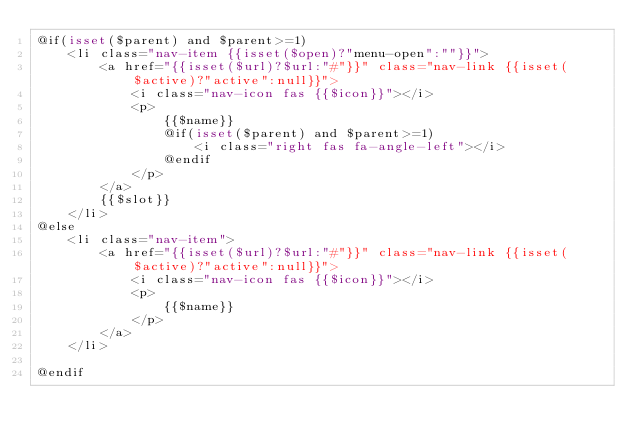<code> <loc_0><loc_0><loc_500><loc_500><_PHP_>@if(isset($parent) and $parent>=1)
    <li class="nav-item {{isset($open)?"menu-open":""}}">
        <a href="{{isset($url)?$url:"#"}}" class="nav-link {{isset($active)?"active":null}}">
            <i class="nav-icon fas {{$icon}}"></i>
            <p>
                {{$name}}
                @if(isset($parent) and $parent>=1)
                    <i class="right fas fa-angle-left"></i>
                @endif
            </p>
        </a>
        {{$slot}}
    </li>
@else
    <li class="nav-item">
        <a href="{{isset($url)?$url:"#"}}" class="nav-link {{isset($active)?"active":null}}">
            <i class="nav-icon fas {{$icon}}"></i>
            <p>
                {{$name}}
            </p>
        </a>
    </li>

@endif
</code> 